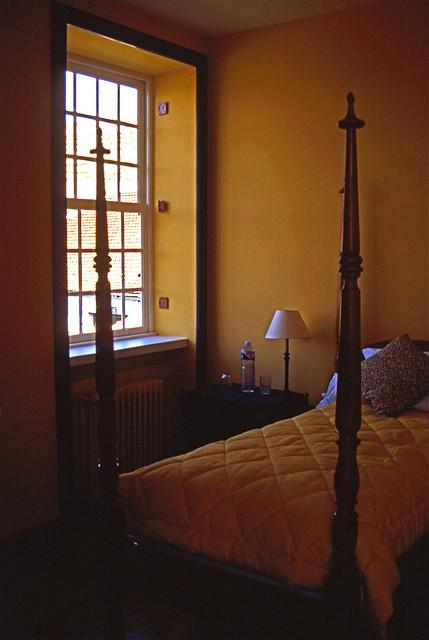What is the tip of the bed structures called? Please explain your reasoning. finials. The tips have a technical name known as the finials. 